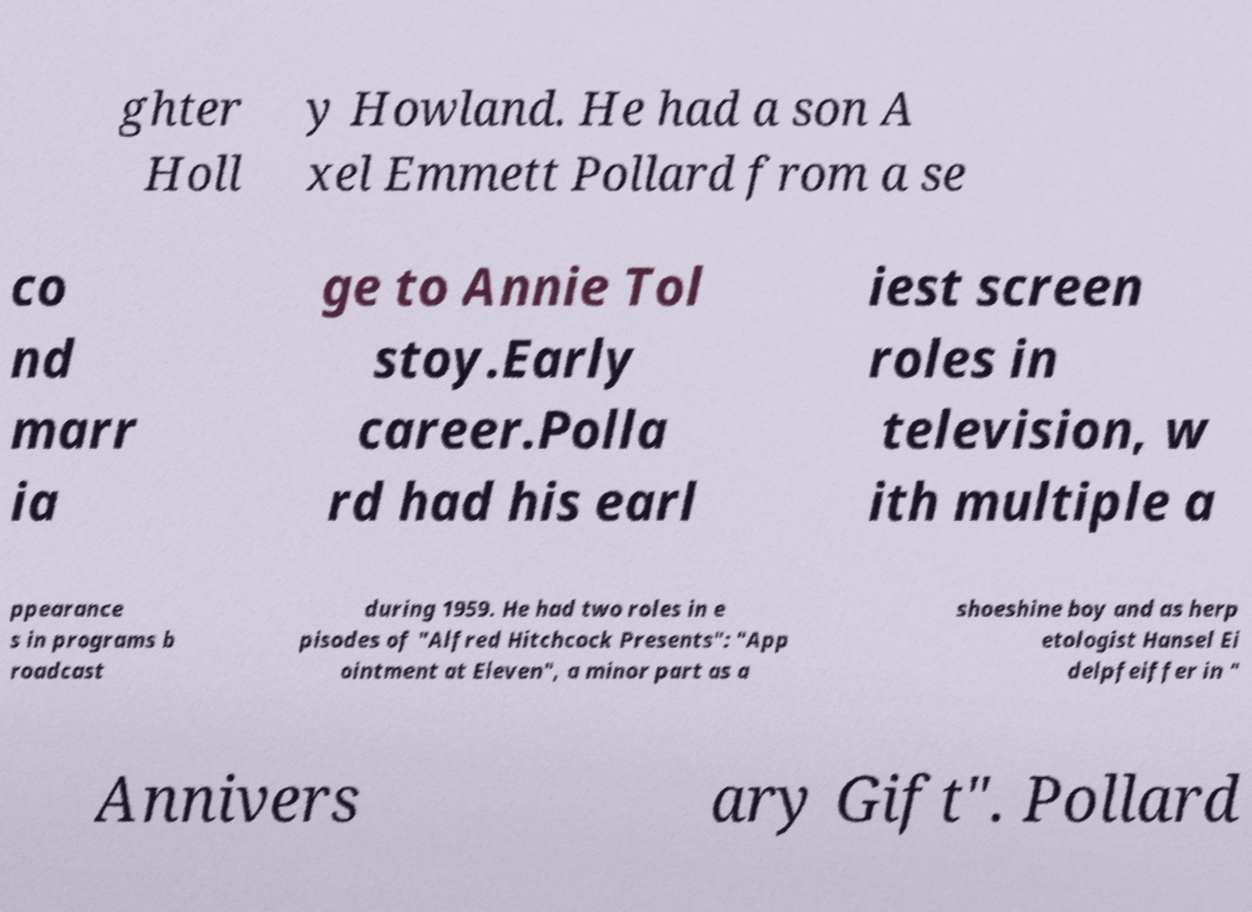What messages or text are displayed in this image? I need them in a readable, typed format. ghter Holl y Howland. He had a son A xel Emmett Pollard from a se co nd marr ia ge to Annie Tol stoy.Early career.Polla rd had his earl iest screen roles in television, w ith multiple a ppearance s in programs b roadcast during 1959. He had two roles in e pisodes of "Alfred Hitchcock Presents": "App ointment at Eleven", a minor part as a shoeshine boy and as herp etologist Hansel Ei delpfeiffer in " Annivers ary Gift". Pollard 